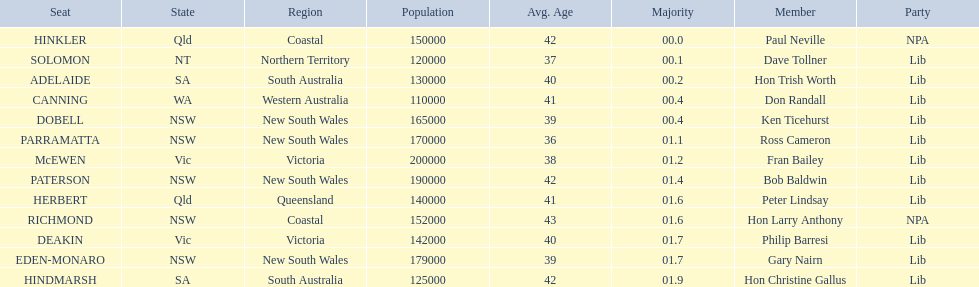Which seats are represented in the electoral system of australia? HINKLER, SOLOMON, ADELAIDE, CANNING, DOBELL, PARRAMATTA, McEWEN, PATERSON, HERBERT, RICHMOND, DEAKIN, EDEN-MONARO, HINDMARSH. What were their majority numbers of both hindmarsh and hinkler? HINKLER, HINDMARSH. Of those two seats, what is the difference in voting majority? 01.9. 